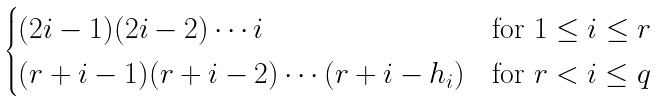<formula> <loc_0><loc_0><loc_500><loc_500>\begin{cases} ( 2 i - 1 ) ( 2 i - 2 ) \cdots i & \text {for $1\leq i \leq r$} \\ ( r + i - 1 ) ( r + i - 2 ) \cdots ( r + i - h _ { i } ) & \text {for $r <i \leq q$} \end{cases}</formula> 